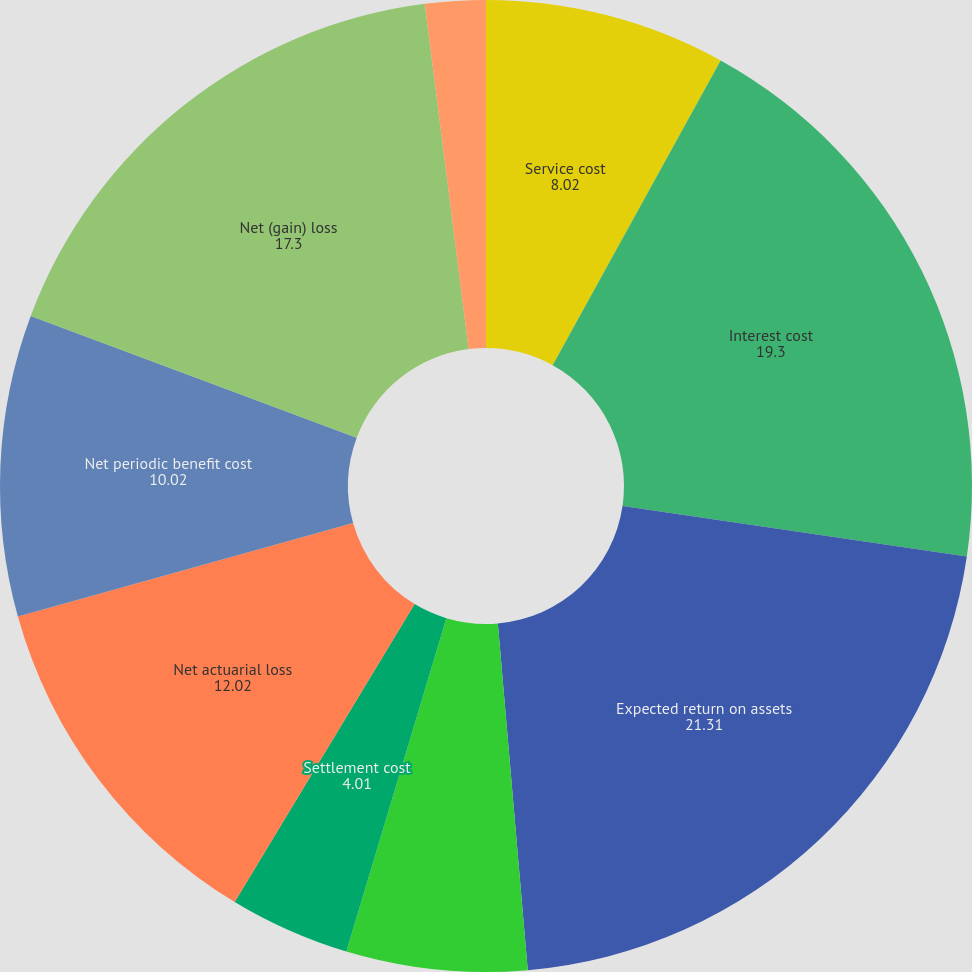Convert chart to OTSL. <chart><loc_0><loc_0><loc_500><loc_500><pie_chart><fcel>Service cost<fcel>Interest cost<fcel>Expected return on assets<fcel>Curtailments<fcel>Settlement cost<fcel>Prior service cost<fcel>Net actuarial loss<fcel>Net periodic benefit cost<fcel>Net (gain) loss<fcel>Prior service credit (cost)<nl><fcel>8.02%<fcel>19.3%<fcel>21.31%<fcel>6.01%<fcel>4.01%<fcel>0.0%<fcel>12.02%<fcel>10.02%<fcel>17.3%<fcel>2.01%<nl></chart> 